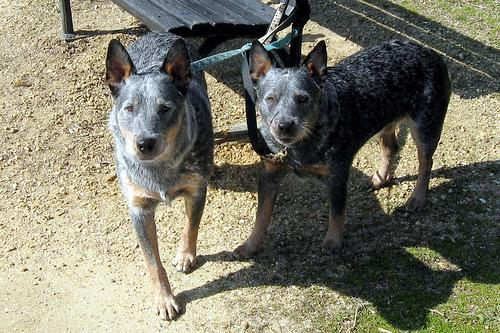What would most likely explain why these dogs look similar?

Choices:
A) dog farm
B) clone
C) family
D) optical illusion family 